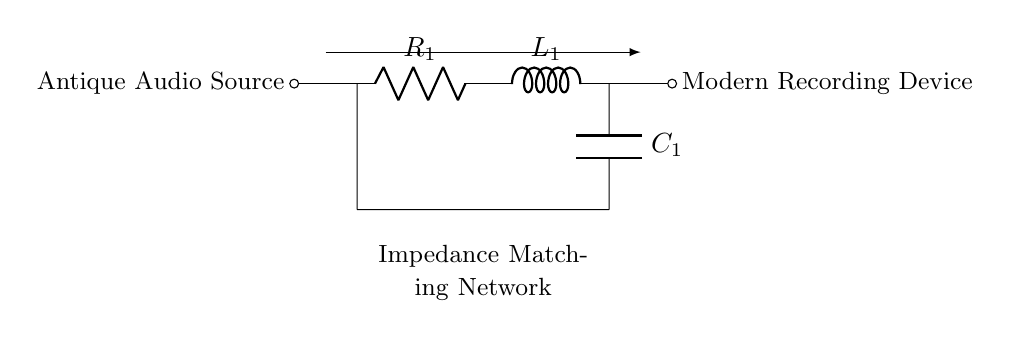What is the function of the resistor in this circuit? The resistor, labeled as R1 in the circuit, is used to limit the current flow from the antique audio source into the impedance matching network, ensuring proper loading and protection of the audio source.
Answer: Current limiting What type of circuit is depicted here? The circuit is an impedance matching network, specifically designed using resistors, inductors, and capacitors to connect modern recording devices to antique audio sources for optimal performance.
Answer: Impedance matching network What is the component that stores electrical energy? The component that stores electrical energy in the circuit is the capacitor, labeled as C1, which charges and discharges in response to the alternating current signals from the audio source.
Answer: Capacitor How many components are in the impedance matching network? The impedance matching network consists of three components: one resistor, one inductor, and one capacitor, which are arranged to optimize the impedance levels for the connected devices.
Answer: Three What is the role of the inductor in this circuit? The inductor, labeled as L1, serves to store magnetic energy and helps to filter or smooth out the audio signal, contributing to the overall impedance matching and response of the circuit.
Answer: Energy storage What is the output device connected to the circuit? The output device is a modern recording device, which is connected at the right end of the circuit, allowing it to receive the appropriately matched audio signals from the antique source.
Answer: Modern recording device What is the primary purpose of this circuit? The primary purpose of this circuit is to match the impedance between the antique audio source and the modern recording device, facilitating effective signal transfer and preserving audio quality.
Answer: Impedance matching 